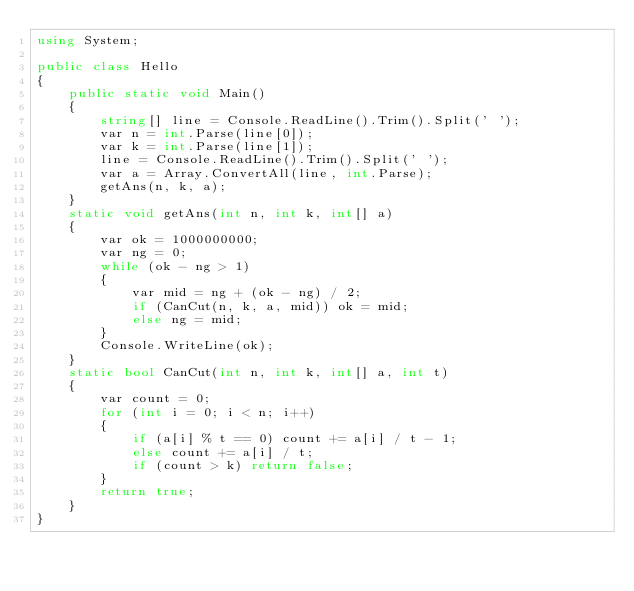<code> <loc_0><loc_0><loc_500><loc_500><_C#_>using System;

public class Hello
{
    public static void Main()
    {
        string[] line = Console.ReadLine().Trim().Split(' ');
        var n = int.Parse(line[0]);
        var k = int.Parse(line[1]);
        line = Console.ReadLine().Trim().Split(' ');
        var a = Array.ConvertAll(line, int.Parse);
        getAns(n, k, a);
    }
    static void getAns(int n, int k, int[] a)
    {
        var ok = 1000000000;
        var ng = 0;
        while (ok - ng > 1)
        {
            var mid = ng + (ok - ng) / 2;
            if (CanCut(n, k, a, mid)) ok = mid;
            else ng = mid;
        }
        Console.WriteLine(ok);
    }
    static bool CanCut(int n, int k, int[] a, int t)
    {
        var count = 0;
        for (int i = 0; i < n; i++)
        {
            if (a[i] % t == 0) count += a[i] / t - 1;
            else count += a[i] / t;
            if (count > k) return false;
        }
        return true;
    }
}
</code> 